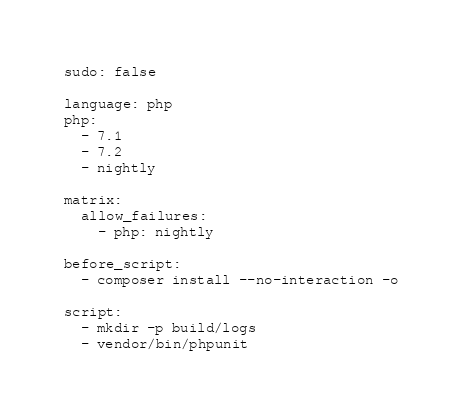<code> <loc_0><loc_0><loc_500><loc_500><_YAML_>sudo: false

language: php
php:
  - 7.1
  - 7.2
  - nightly

matrix:
  allow_failures:
    - php: nightly

before_script:
  - composer install --no-interaction -o

script:
  - mkdir -p build/logs
  - vendor/bin/phpunit
</code> 